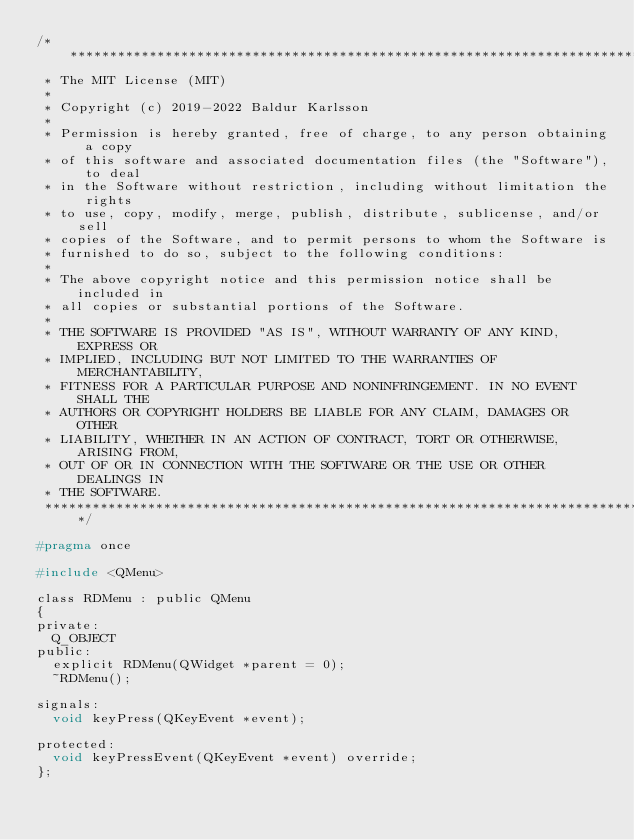<code> <loc_0><loc_0><loc_500><loc_500><_C_>/******************************************************************************
 * The MIT License (MIT)
 *
 * Copyright (c) 2019-2022 Baldur Karlsson
 *
 * Permission is hereby granted, free of charge, to any person obtaining a copy
 * of this software and associated documentation files (the "Software"), to deal
 * in the Software without restriction, including without limitation the rights
 * to use, copy, modify, merge, publish, distribute, sublicense, and/or sell
 * copies of the Software, and to permit persons to whom the Software is
 * furnished to do so, subject to the following conditions:
 *
 * The above copyright notice and this permission notice shall be included in
 * all copies or substantial portions of the Software.
 *
 * THE SOFTWARE IS PROVIDED "AS IS", WITHOUT WARRANTY OF ANY KIND, EXPRESS OR
 * IMPLIED, INCLUDING BUT NOT LIMITED TO THE WARRANTIES OF MERCHANTABILITY,
 * FITNESS FOR A PARTICULAR PURPOSE AND NONINFRINGEMENT. IN NO EVENT SHALL THE
 * AUTHORS OR COPYRIGHT HOLDERS BE LIABLE FOR ANY CLAIM, DAMAGES OR OTHER
 * LIABILITY, WHETHER IN AN ACTION OF CONTRACT, TORT OR OTHERWISE, ARISING FROM,
 * OUT OF OR IN CONNECTION WITH THE SOFTWARE OR THE USE OR OTHER DEALINGS IN
 * THE SOFTWARE.
 ******************************************************************************/

#pragma once

#include <QMenu>

class RDMenu : public QMenu
{
private:
  Q_OBJECT
public:
  explicit RDMenu(QWidget *parent = 0);
  ~RDMenu();

signals:
  void keyPress(QKeyEvent *event);

protected:
  void keyPressEvent(QKeyEvent *event) override;
};
</code> 